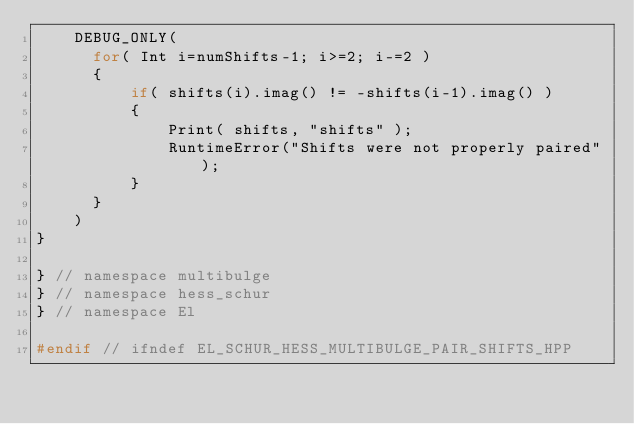Convert code to text. <code><loc_0><loc_0><loc_500><loc_500><_C++_>    DEBUG_ONLY(
      for( Int i=numShifts-1; i>=2; i-=2 )
      {
          if( shifts(i).imag() != -shifts(i-1).imag() )
          {
              Print( shifts, "shifts" );
              RuntimeError("Shifts were not properly paired");
          }
      }
    )
}

} // namespace multibulge
} // namespace hess_schur
} // namespace El

#endif // ifndef EL_SCHUR_HESS_MULTIBULGE_PAIR_SHIFTS_HPP
</code> 